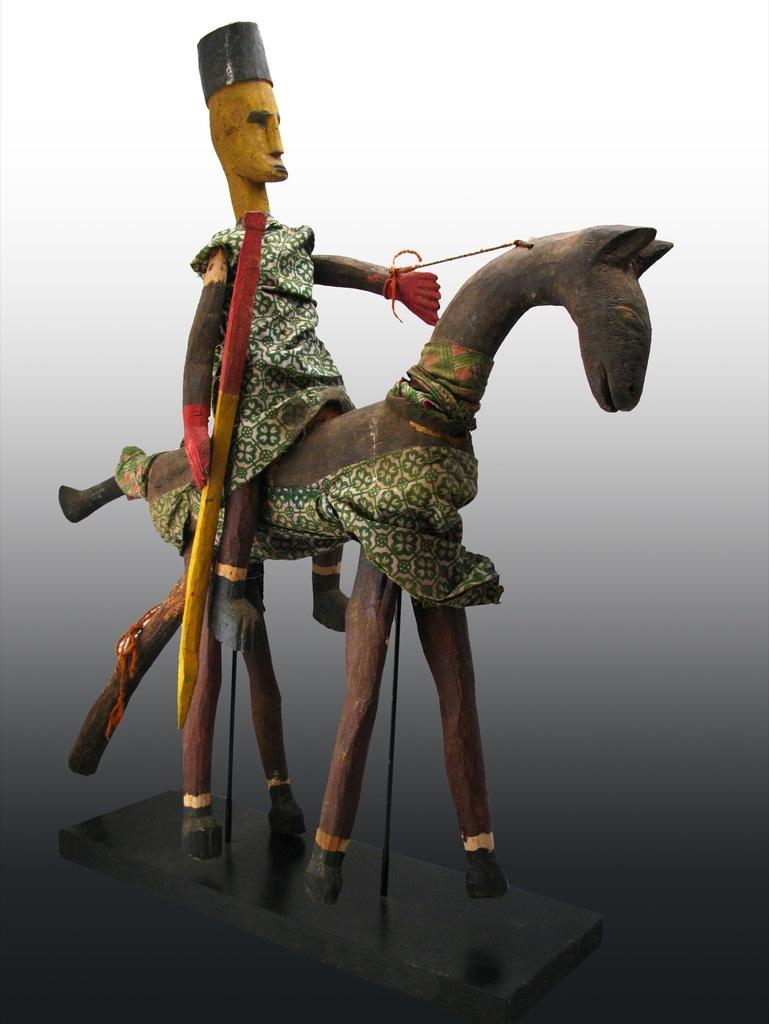What types of toys are present in the image? There is a toy of a person and a toy of an animal in the image. What type of border is depicted in the image? There is no border present in the image; it features two toys, one of a person and one of an animal. What type of system is being used to sail in the image? There is no sail or sailing system present in the image; it features two toys, one of a person and one of an animal. 